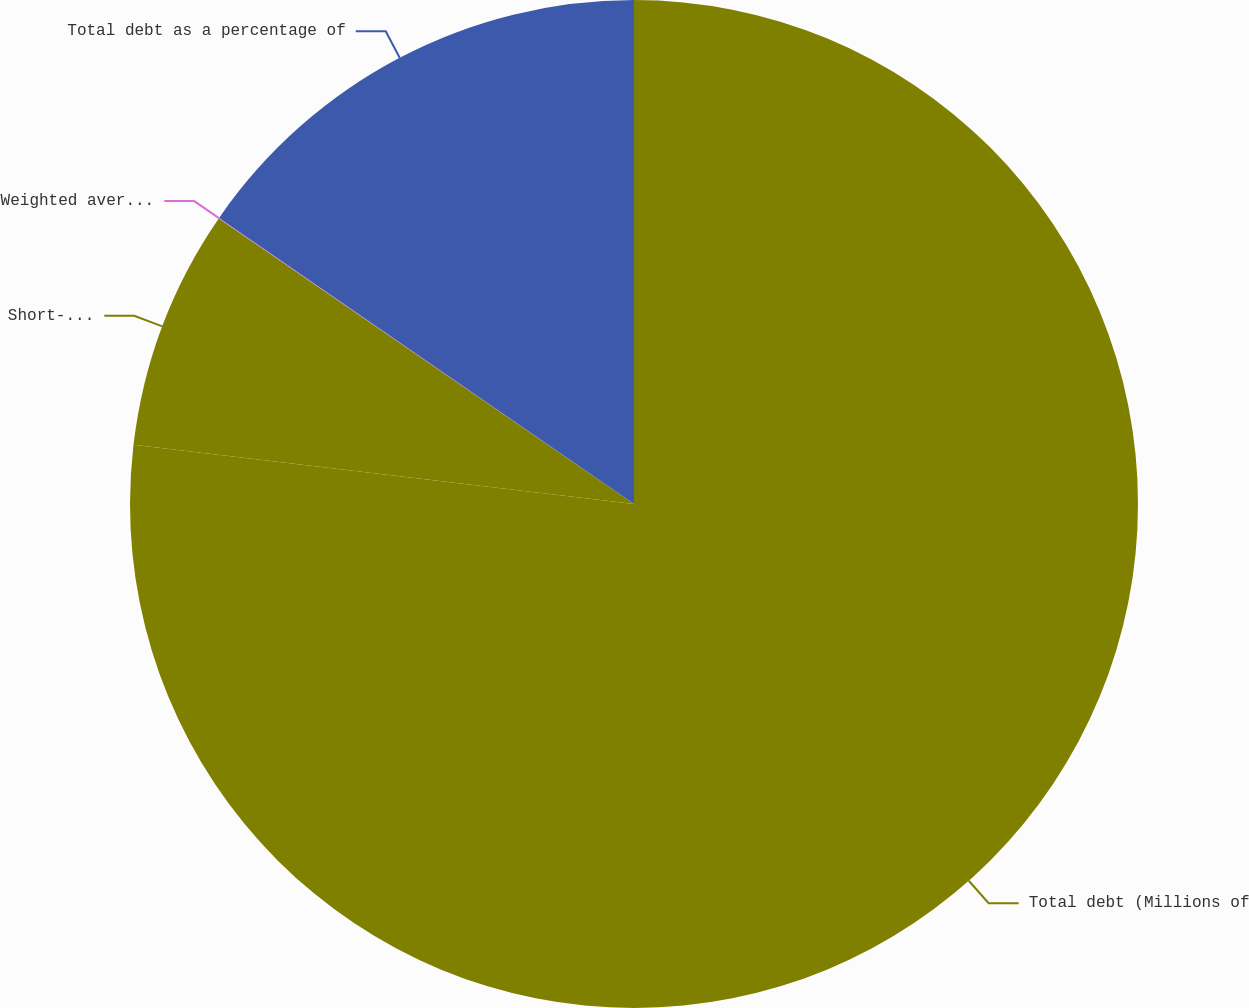<chart> <loc_0><loc_0><loc_500><loc_500><pie_chart><fcel>Total debt (Millions of<fcel>Short-term debt as a<fcel>Weighted average cost of total<fcel>Total debt as a percentage of<nl><fcel>76.87%<fcel>7.71%<fcel>0.02%<fcel>15.39%<nl></chart> 